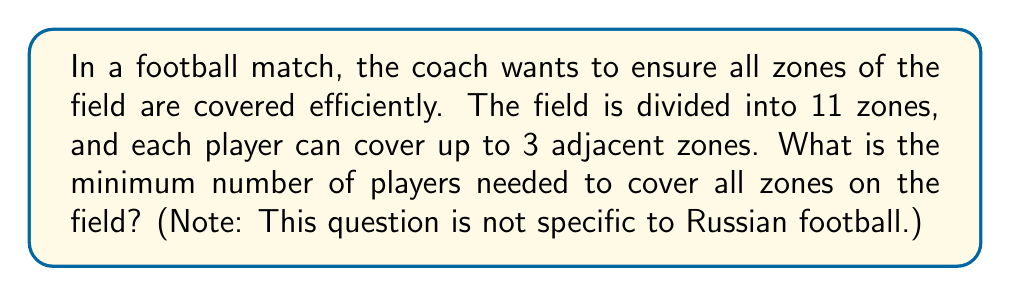Help me with this question. To solve this problem, we can use concepts from graph theory, specifically the vertex cover problem. Let's approach this step-by-step:

1) First, we model the football field as a graph:
   - Each zone is represented by a vertex.
   - Adjacent zones are connected by edges.

2) Given that the field is divided into 11 zones, we have a graph with 11 vertices.

3) Each player can cover up to 3 adjacent zones, which means they can cover a vertex and its two adjacent vertices in the graph.

4) The problem now becomes finding the minimum vertex cover of this graph, where each vertex in the cover can also cover its two neighbors.

5) To minimize the number of players, we need to find a set of vertices such that:
   - Every edge in the graph is incident to at least one vertex in the set.
   - The set is as small as possible.

6) In this case, we can cover the entire graph with 4 players:
   - Player 1 covers zones 1, 2, and 3
   - Player 2 covers zones 4, 5, and 6
   - Player 3 covers zones 7, 8, and 9
   - Player 4 covers zones 10 and 11, and can also assist with zone 9

7) Mathematically, we can express this as:

   $$\text{Minimum players} = \left\lceil\frac{11}{3}\right\rceil = 4$$

   Where $\lceil \cdot \rceil$ denotes the ceiling function.

8) This solution ensures that all 11 zones are covered with the minimum number of players, given the constraint that each player can cover up to 3 adjacent zones.
Answer: The minimum number of players needed to cover all 11 zones on the football field is 4. 